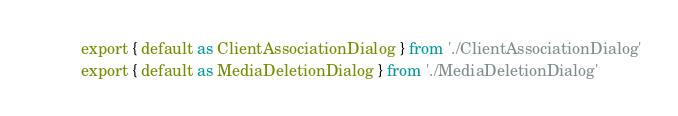<code> <loc_0><loc_0><loc_500><loc_500><_JavaScript_>export { default as ClientAssociationDialog } from './ClientAssociationDialog'
export { default as MediaDeletionDialog } from './MediaDeletionDialog'
</code> 